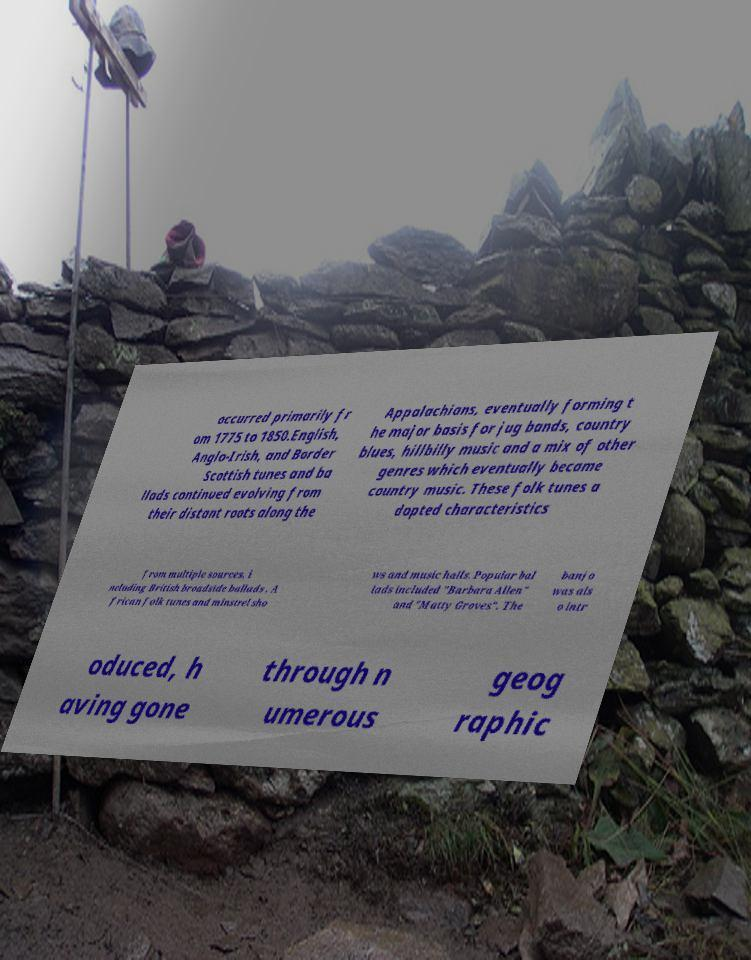I need the written content from this picture converted into text. Can you do that? occurred primarily fr om 1775 to 1850.English, Anglo-Irish, and Border Scottish tunes and ba llads continued evolving from their distant roots along the Appalachians, eventually forming t he major basis for jug bands, country blues, hillbilly music and a mix of other genres which eventually became country music. These folk tunes a dopted characteristics from multiple sources, i ncluding British broadside ballads , A frican folk tunes and minstrel sho ws and music halls. Popular bal lads included "Barbara Allen" and "Matty Groves". The banjo was als o intr oduced, h aving gone through n umerous geog raphic 